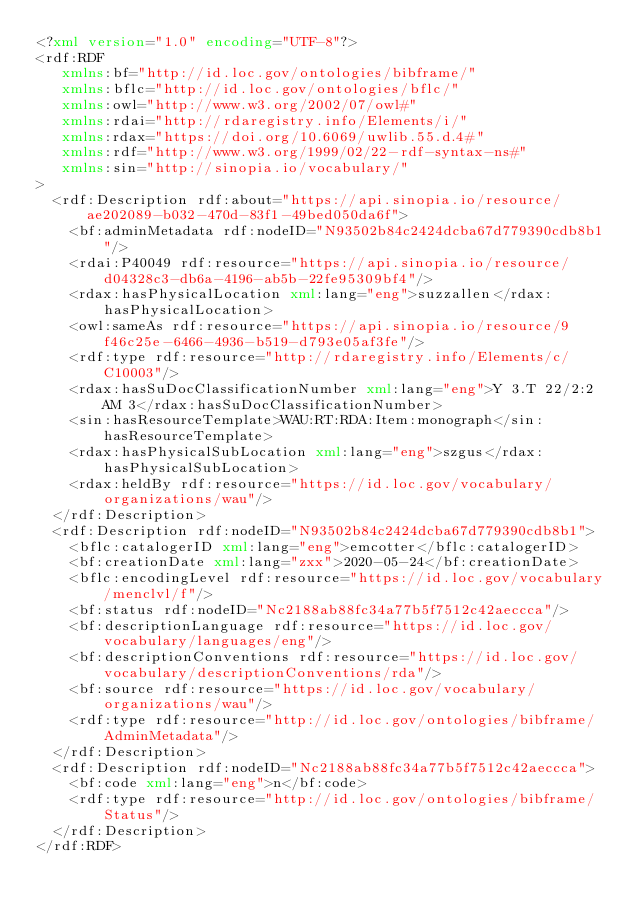<code> <loc_0><loc_0><loc_500><loc_500><_XML_><?xml version="1.0" encoding="UTF-8"?>
<rdf:RDF
   xmlns:bf="http://id.loc.gov/ontologies/bibframe/"
   xmlns:bflc="http://id.loc.gov/ontologies/bflc/"
   xmlns:owl="http://www.w3.org/2002/07/owl#"
   xmlns:rdai="http://rdaregistry.info/Elements/i/"
   xmlns:rdax="https://doi.org/10.6069/uwlib.55.d.4#"
   xmlns:rdf="http://www.w3.org/1999/02/22-rdf-syntax-ns#"
   xmlns:sin="http://sinopia.io/vocabulary/"
>
  <rdf:Description rdf:about="https://api.sinopia.io/resource/ae202089-b032-470d-83f1-49bed050da6f">
    <bf:adminMetadata rdf:nodeID="N93502b84c2424dcba67d779390cdb8b1"/>
    <rdai:P40049 rdf:resource="https://api.sinopia.io/resource/d04328c3-db6a-4196-ab5b-22fe95309bf4"/>
    <rdax:hasPhysicalLocation xml:lang="eng">suzzallen</rdax:hasPhysicalLocation>
    <owl:sameAs rdf:resource="https://api.sinopia.io/resource/9f46c25e-6466-4936-b519-d793e05af3fe"/>
    <rdf:type rdf:resource="http://rdaregistry.info/Elements/c/C10003"/>
    <rdax:hasSuDocClassificationNumber xml:lang="eng">Y 3.T 22/2:2 AM 3</rdax:hasSuDocClassificationNumber>
    <sin:hasResourceTemplate>WAU:RT:RDA:Item:monograph</sin:hasResourceTemplate>
    <rdax:hasPhysicalSubLocation xml:lang="eng">szgus</rdax:hasPhysicalSubLocation>
    <rdax:heldBy rdf:resource="https://id.loc.gov/vocabulary/organizations/wau"/>
  </rdf:Description>
  <rdf:Description rdf:nodeID="N93502b84c2424dcba67d779390cdb8b1">
    <bflc:catalogerID xml:lang="eng">emcotter</bflc:catalogerID>
    <bf:creationDate xml:lang="zxx">2020-05-24</bf:creationDate>
    <bflc:encodingLevel rdf:resource="https://id.loc.gov/vocabulary/menclvl/f"/>
    <bf:status rdf:nodeID="Nc2188ab88fc34a77b5f7512c42aeccca"/>
    <bf:descriptionLanguage rdf:resource="https://id.loc.gov/vocabulary/languages/eng"/>
    <bf:descriptionConventions rdf:resource="https://id.loc.gov/vocabulary/descriptionConventions/rda"/>
    <bf:source rdf:resource="https://id.loc.gov/vocabulary/organizations/wau"/>
    <rdf:type rdf:resource="http://id.loc.gov/ontologies/bibframe/AdminMetadata"/>
  </rdf:Description>
  <rdf:Description rdf:nodeID="Nc2188ab88fc34a77b5f7512c42aeccca">
    <bf:code xml:lang="eng">n</bf:code>
    <rdf:type rdf:resource="http://id.loc.gov/ontologies/bibframe/Status"/>
  </rdf:Description>
</rdf:RDF>
</code> 